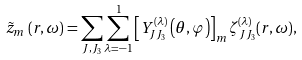<formula> <loc_0><loc_0><loc_500><loc_500>\tilde { z } _ { m } \left ( { r } , \omega \right ) = \sum _ { J , J _ { 3 } } \sum _ { \lambda = - 1 } ^ { 1 } \left [ { Y } ^ { ( \lambda ) } _ { J J _ { 3 } } \left ( \theta , \varphi \right ) \right ] _ { m } \zeta ^ { ( \lambda ) } _ { J J _ { 3 } } ( r , \omega ) ,</formula> 